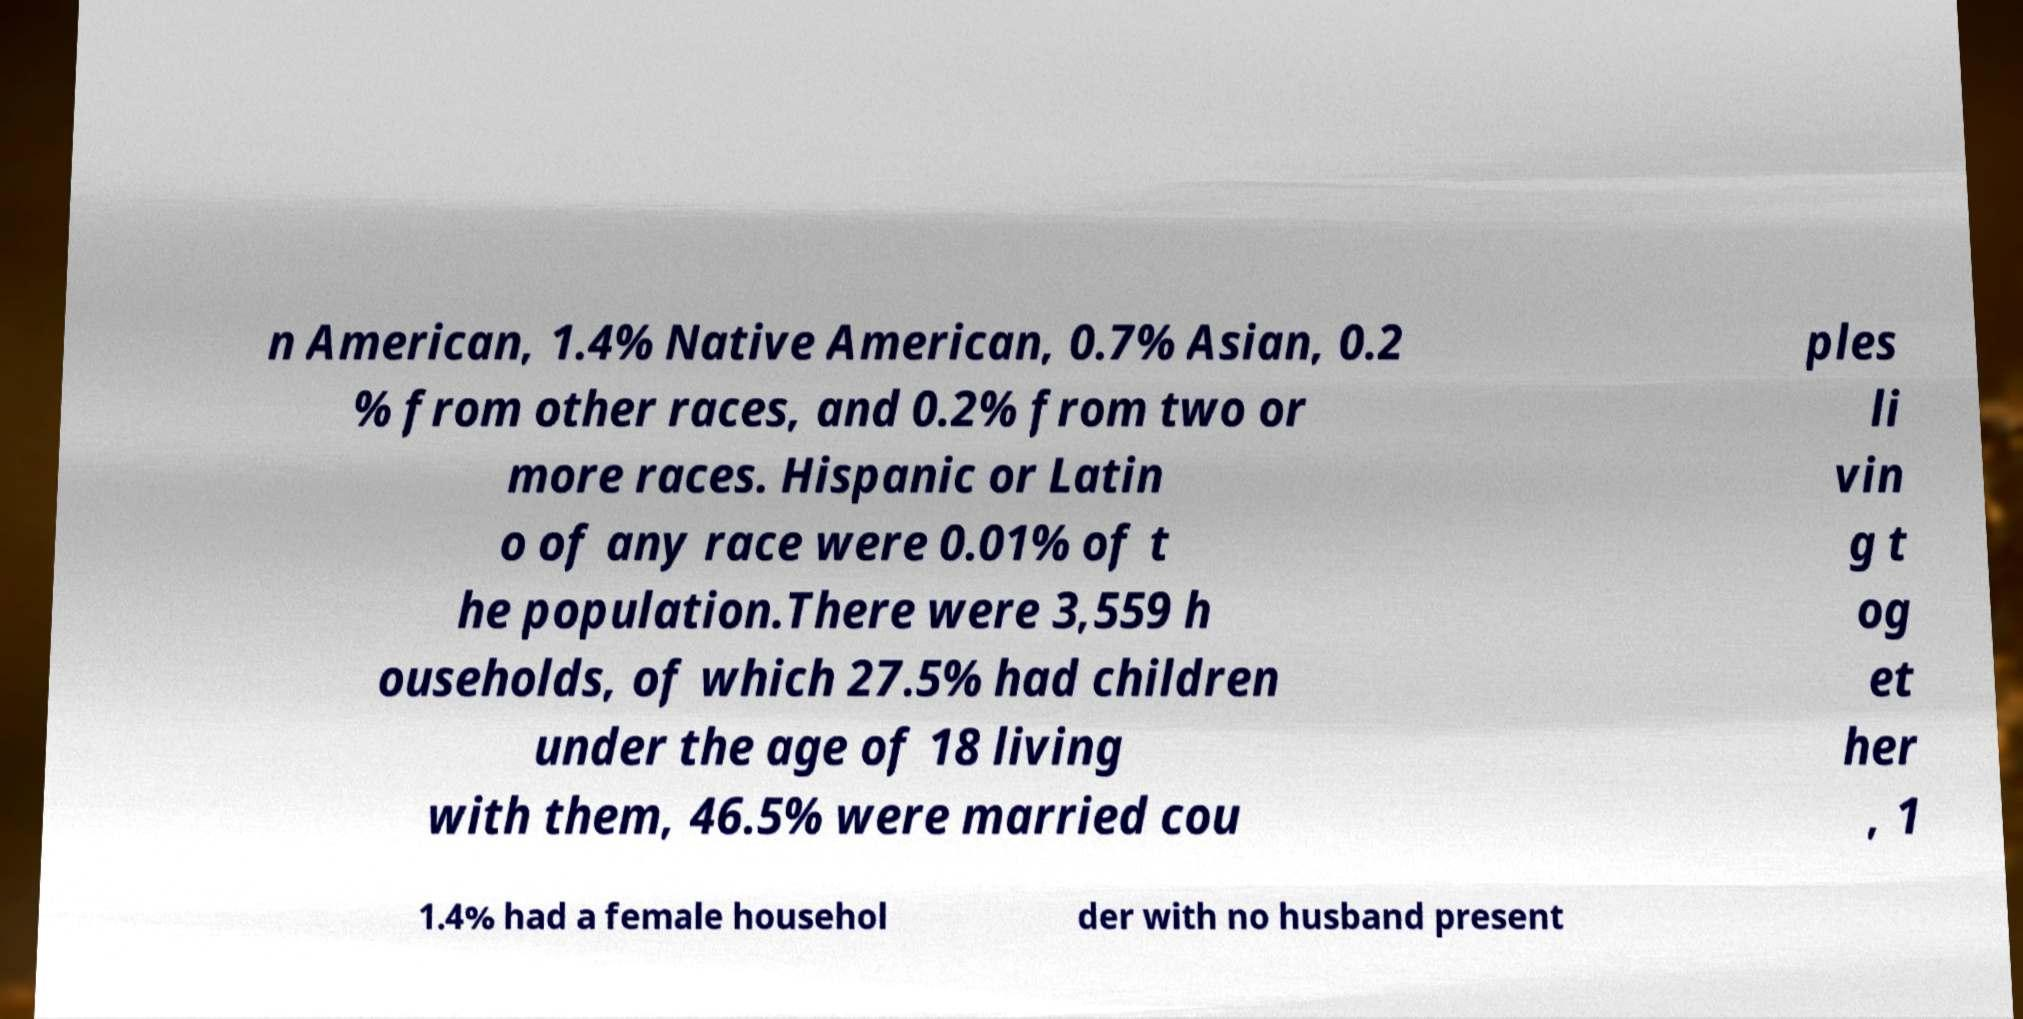Can you read and provide the text displayed in the image?This photo seems to have some interesting text. Can you extract and type it out for me? n American, 1.4% Native American, 0.7% Asian, 0.2 % from other races, and 0.2% from two or more races. Hispanic or Latin o of any race were 0.01% of t he population.There were 3,559 h ouseholds, of which 27.5% had children under the age of 18 living with them, 46.5% were married cou ples li vin g t og et her , 1 1.4% had a female househol der with no husband present 